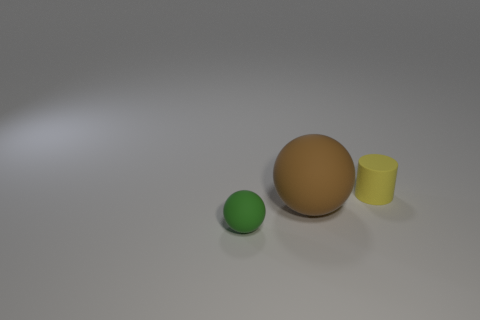Add 1 small green rubber balls. How many objects exist? 4 Subtract all spheres. How many objects are left? 1 Subtract 0 cyan cubes. How many objects are left? 3 Subtract all cyan metallic balls. Subtract all small yellow matte objects. How many objects are left? 2 Add 3 yellow matte objects. How many yellow matte objects are left? 4 Add 3 spheres. How many spheres exist? 5 